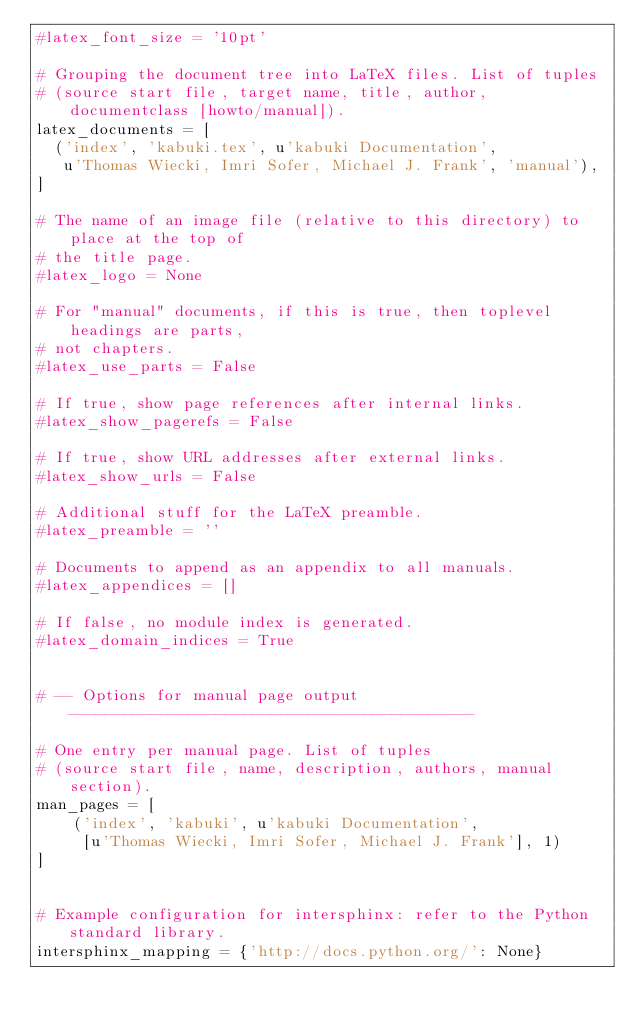<code> <loc_0><loc_0><loc_500><loc_500><_Python_>#latex_font_size = '10pt'

# Grouping the document tree into LaTeX files. List of tuples
# (source start file, target name, title, author, documentclass [howto/manual]).
latex_documents = [
  ('index', 'kabuki.tex', u'kabuki Documentation',
   u'Thomas Wiecki, Imri Sofer, Michael J. Frank', 'manual'),
]

# The name of an image file (relative to this directory) to place at the top of
# the title page.
#latex_logo = None

# For "manual" documents, if this is true, then toplevel headings are parts,
# not chapters.
#latex_use_parts = False

# If true, show page references after internal links.
#latex_show_pagerefs = False

# If true, show URL addresses after external links.
#latex_show_urls = False

# Additional stuff for the LaTeX preamble.
#latex_preamble = ''

# Documents to append as an appendix to all manuals.
#latex_appendices = []

# If false, no module index is generated.
#latex_domain_indices = True


# -- Options for manual page output --------------------------------------------

# One entry per manual page. List of tuples
# (source start file, name, description, authors, manual section).
man_pages = [
    ('index', 'kabuki', u'kabuki Documentation',
     [u'Thomas Wiecki, Imri Sofer, Michael J. Frank'], 1)
]


# Example configuration for intersphinx: refer to the Python standard library.
intersphinx_mapping = {'http://docs.python.org/': None}
</code> 